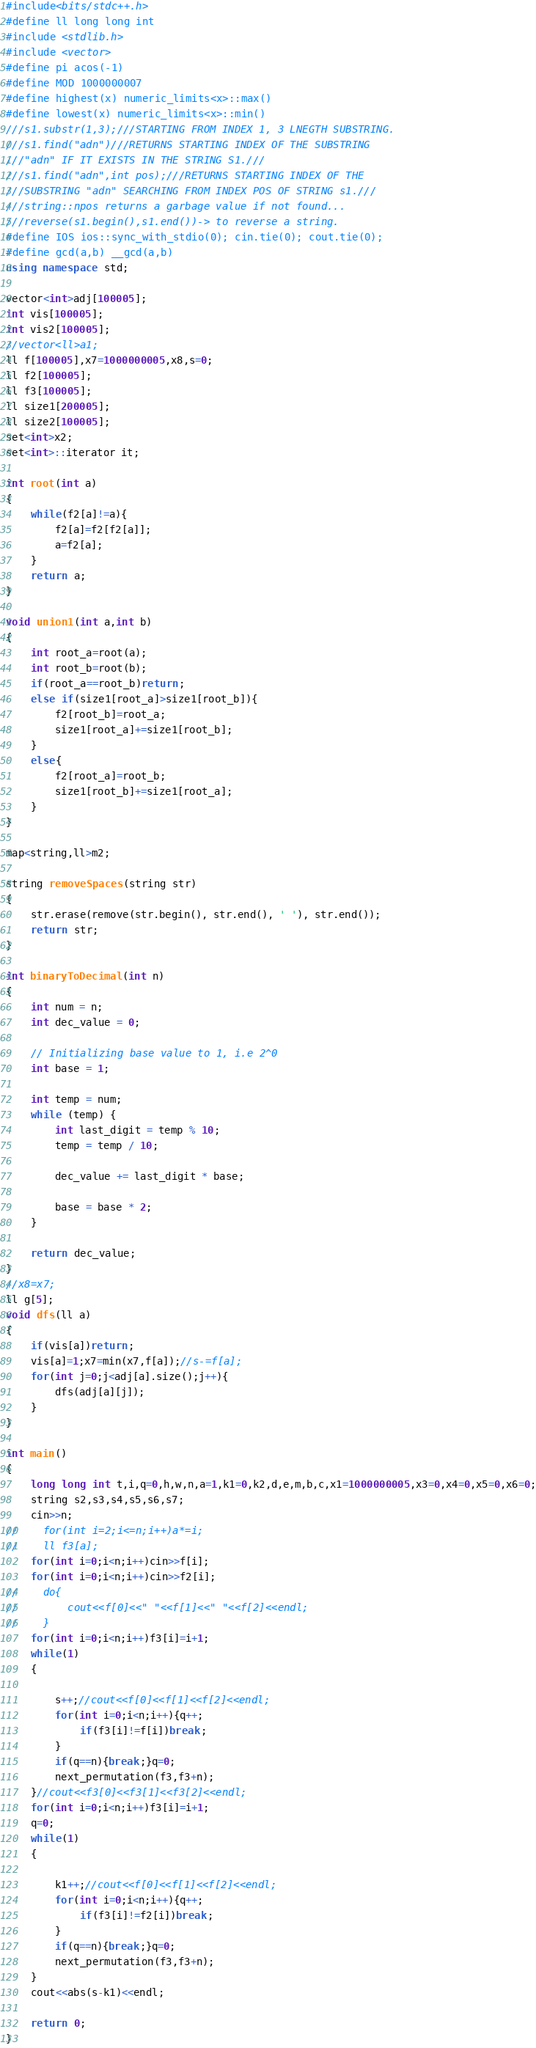Convert code to text. <code><loc_0><loc_0><loc_500><loc_500><_C++_>#include<bits/stdc++.h>
#define ll long long int
#include <stdlib.h>
#include <vector>
#define pi acos(-1)
#define MOD 1000000007
#define highest(x) numeric_limits<x>::max()
#define lowest(x) numeric_limits<x>::min()
///s1.substr(1,3);///STARTING FROM INDEX 1, 3 LNEGTH SUBSTRING.
///s1.find("adn")///RETURNS STARTING INDEX OF THE SUBSTRING
///"adn" IF IT EXISTS IN THE STRING S1.///
///s1.find("adn",int pos);///RETURNS STARTING INDEX OF THE
///SUBSTRING "adn" SEARCHING FROM INDEX POS OF STRING s1.///
///string::npos returns a garbage value if not found...
///reverse(s1.begin(),s1.end())-> to reverse a string.
#define IOS ios::sync_with_stdio(0); cin.tie(0); cout.tie(0);
#define gcd(a,b) __gcd(a,b)
using namespace std;

vector<int>adj[100005];
int vis[100005];
int vis2[100005];
//vector<ll>a1;
ll f[100005],x7=1000000005,x8,s=0;
ll f2[100005];
ll f3[100005];
ll size1[200005];
ll size2[100005];
set<int>x2;
set<int>::iterator it;

int root(int a)
{
    while(f2[a]!=a){
        f2[a]=f2[f2[a]];
        a=f2[a];
    }
    return a;
}

void union1(int a,int b)
{
    int root_a=root(a);
    int root_b=root(b);
    if(root_a==root_b)return;
    else if(size1[root_a]>size1[root_b]){
        f2[root_b]=root_a;
        size1[root_a]+=size1[root_b];
    }
    else{
        f2[root_a]=root_b;
        size1[root_b]+=size1[root_a];
    }
}

map<string,ll>m2;

string removeSpaces(string str)
{
    str.erase(remove(str.begin(), str.end(), ' '), str.end());
    return str;
}

int binaryToDecimal(int n)
{
    int num = n;
    int dec_value = 0;

    // Initializing base value to 1, i.e 2^0
    int base = 1;

    int temp = num;
    while (temp) {
        int last_digit = temp % 10;
        temp = temp / 10;

        dec_value += last_digit * base;

        base = base * 2;
    }

    return dec_value;
}
//x8=x7;
ll g[5];
void dfs(ll a)
{
    if(vis[a])return;
    vis[a]=1;x7=min(x7,f[a]);//s-=f[a];
    for(int j=0;j<adj[a].size();j++){
        dfs(adj[a][j]);
    }
}

int main()
{
    long long int t,i,q=0,h,w,n,a=1,k1=0,k2,d,e,m,b,c,x1=1000000005,x3=0,x4=0,x5=0,x6=0;
    string s2,s3,s4,s5,s6,s7;
    cin>>n;
//    for(int i=2;i<=n;i++)a*=i;
//    ll f3[a];
    for(int i=0;i<n;i++)cin>>f[i];
    for(int i=0;i<n;i++)cin>>f2[i];
//    do{
//        cout<<f[0]<<" "<<f[1]<<" "<<f[2]<<endl;
//    }
    for(int i=0;i<n;i++)f3[i]=i+1;
    while(1)
    {

        s++;//cout<<f[0]<<f[1]<<f[2]<<endl;
        for(int i=0;i<n;i++){q++;
            if(f3[i]!=f[i])break;
        }
        if(q==n){break;}q=0;
        next_permutation(f3,f3+n);
    }//cout<<f3[0]<<f3[1]<<f3[2]<<endl;
    for(int i=0;i<n;i++)f3[i]=i+1;
    q=0;
    while(1)
    {

        k1++;//cout<<f[0]<<f[1]<<f[2]<<endl;
        for(int i=0;i<n;i++){q++;
            if(f3[i]!=f2[i])break;
        }
        if(q==n){break;}q=0;
        next_permutation(f3,f3+n);
    }
    cout<<abs(s-k1)<<endl;

    return 0;
}
</code> 